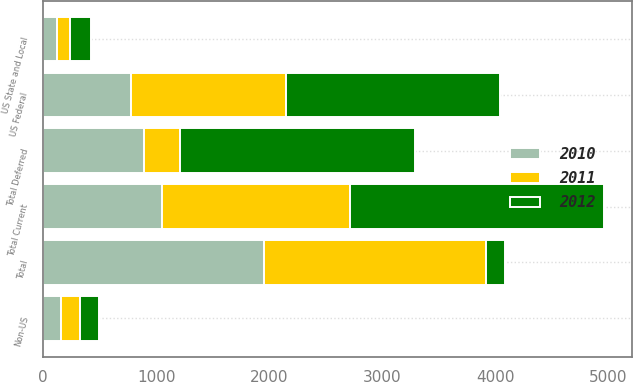Convert chart. <chart><loc_0><loc_0><loc_500><loc_500><stacked_bar_chart><ecel><fcel>US Federal<fcel>US State and Local<fcel>Non-US<fcel>Total Current<fcel>Total Deferred<fcel>Total<nl><fcel>2012<fcel>1901<fcel>182<fcel>167<fcel>2250<fcel>2083<fcel>167<nl><fcel>2011<fcel>1371<fcel>121<fcel>166<fcel>1658<fcel>314<fcel>1972<nl><fcel>2010<fcel>776<fcel>119<fcel>161<fcel>1056<fcel>896<fcel>1952<nl></chart> 